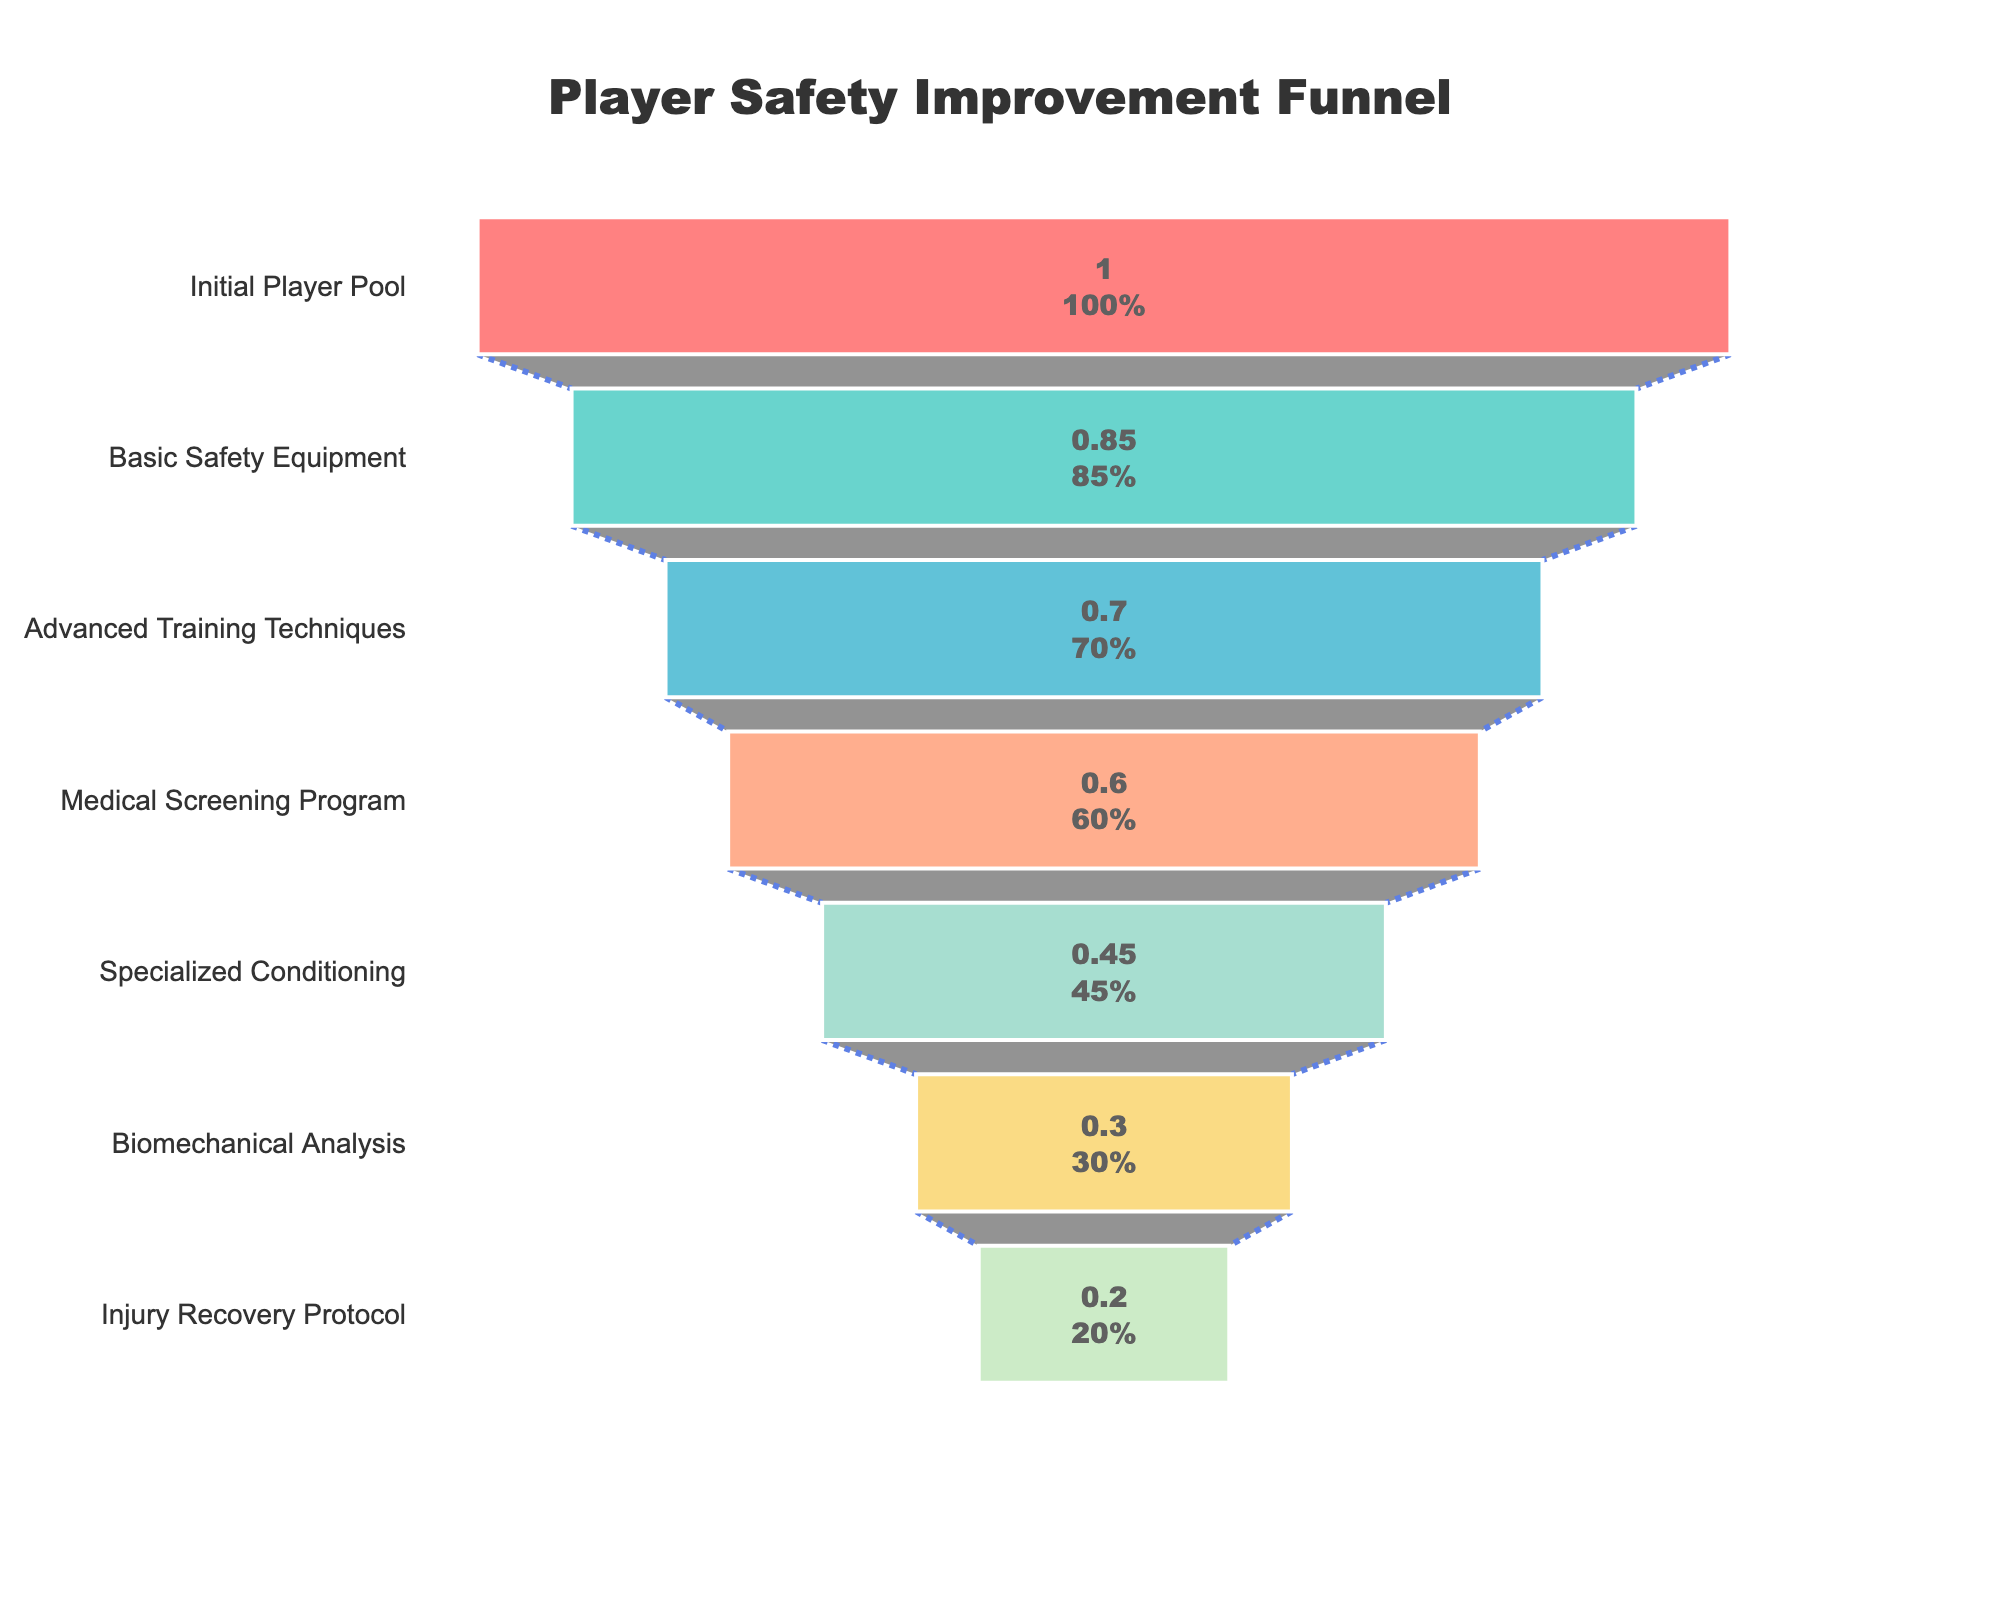What is the percentage of players who underwent comprehensive health checks? Locate the "Medical Screening Program" stage in the funnel chart and refer to the corresponding percentage.
Answer: 60% How many stages are illustrated in the player safety improvement funnel? Count the number of unique stages listed on the y-axis of the funnel chart.
Answer: 7 Which stage represents the steepest drop in percentage of players? Compare the percentage differences between consecutive stages and identify the largest drop. The steepest drop is between the "Specialized Conditioning" (45%) and "Biomechanical Analysis" (30%) stages (a difference of 15%).
Answer: Specialized Conditioning to Biomechanical Analysis What is the difference in percentage between players who received advanced training and those who were successfully rehabilitated? Find the percentages for "Advanced Training Techniques" (70%) and "Injury Recovery Protocol" (20%), then subtract the latter from the former (70% - 20%).
Answer: 50% What proportion of the initial player pool enrolled in personalized fitness programs? Refer to the "Specialized Conditioning" stage in the funnel chart and note the percentage.
Answer: 45% Which stage follows after players are enrolled in personalized fitness programs? Identify the stage that is listed immediately after "Specialized Conditioning" in the sequence.
Answer: Biomechanical Analysis What is the percentage reduction between the initial player pool and the players successfully rehabilitated? Subtract the percentage of "Injury Recovery Protocol" (20%) from the "Initial Player Pool" (100%).
Answer: 80% At which stage do three out of five players remain from the initial player pool? Look for the stage where approximately 60% of the initial players remain. This is the "Medical Screening Program" stage.
Answer: Medical Screening Program Is the percentage of players with mandatory protective gear greater or less than those trained in injury prevention methods? Compare the percentages for "Basic Safety Equipment" (85%) and "Advanced Training Techniques" (70%). 85% is greater than 70%.
Answer: Greater What can you infer about the effectiveness of the safety measures over time based on the funnel chart? As stages progress from the initial player pool to the injury recovery protocol, the percentage of players decreases incrementally, indicating a structured and step-wise implementation of safety measures that systematically reduce the number of players reaching the final stages.
Answer: Safety measures systematically reduce player numbers 